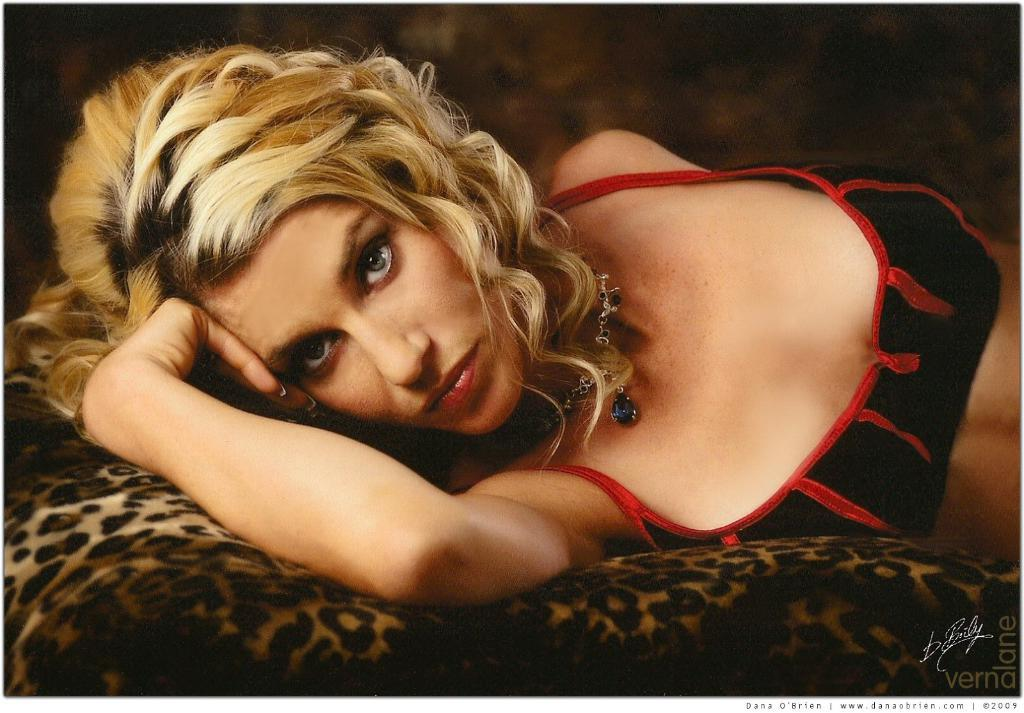Who is present in the image? There is a woman in the image. What is the woman doing in the image? The woman is sleeping on a sofa. What is the woman wearing in the image? The woman is wearing a chain and some jewelry. What might the woman be looking at in the image? The woman appears to be looking at something, but it is not clear what it is from the image. What type of quill is the woman holding in the image? There is no quill present in the image; the woman is sleeping on a sofa and not holding any writing instrument. 